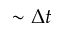<formula> <loc_0><loc_0><loc_500><loc_500>\sim \Delta t</formula> 